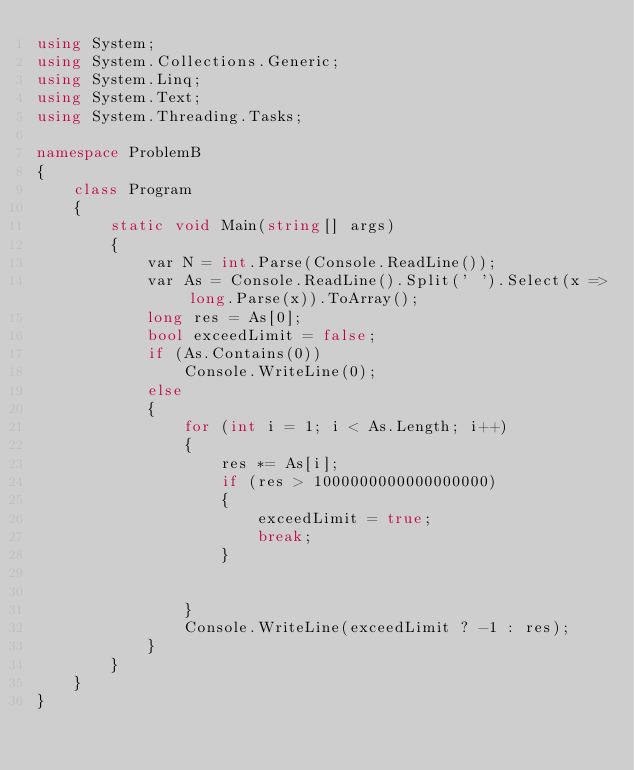<code> <loc_0><loc_0><loc_500><loc_500><_C#_>using System;
using System.Collections.Generic;
using System.Linq;
using System.Text;
using System.Threading.Tasks;

namespace ProblemB
{
    class Program
    {
        static void Main(string[] args)
        {
            var N = int.Parse(Console.ReadLine());
            var As = Console.ReadLine().Split(' ').Select(x => long.Parse(x)).ToArray();
            long res = As[0];
            bool exceedLimit = false;
            if (As.Contains(0))
                Console.WriteLine(0);
            else
            {
                for (int i = 1; i < As.Length; i++)
                {
                    res *= As[i];
                    if (res > 1000000000000000000)
                    {
                        exceedLimit = true;
                        break;
                    }


                }
                Console.WriteLine(exceedLimit ? -1 : res);
            }
        }
    }
}
</code> 